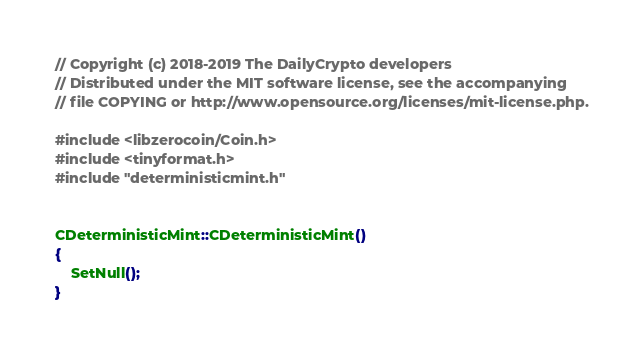<code> <loc_0><loc_0><loc_500><loc_500><_C++_>// Copyright (c) 2018-2019 The DailyCrypto developers
// Distributed under the MIT software license, see the accompanying
// file COPYING or http://www.opensource.org/licenses/mit-license.php.

#include <libzerocoin/Coin.h>
#include <tinyformat.h>
#include "deterministicmint.h"


CDeterministicMint::CDeterministicMint()
{
    SetNull();
}
</code> 